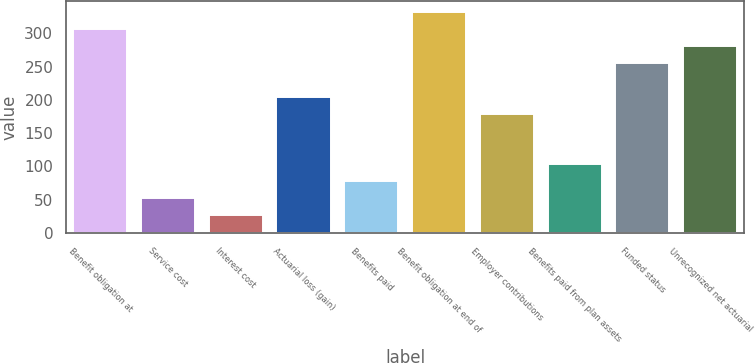<chart> <loc_0><loc_0><loc_500><loc_500><bar_chart><fcel>Benefit obligation at<fcel>Service cost<fcel>Interest cost<fcel>Actuarial loss (gain)<fcel>Benefits paid<fcel>Benefit obligation at end of<fcel>Employer contributions<fcel>Benefits paid from plan assets<fcel>Funded status<fcel>Unrecognized net actuarial<nl><fcel>306.16<fcel>52.86<fcel>27.53<fcel>204.84<fcel>78.19<fcel>331.49<fcel>179.51<fcel>103.52<fcel>255.5<fcel>280.83<nl></chart> 